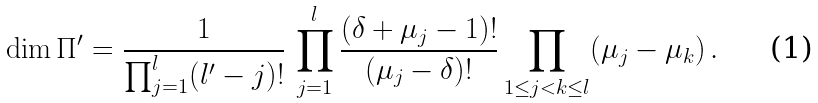Convert formula to latex. <formula><loc_0><loc_0><loc_500><loc_500>\dim \Pi ^ { \prime } = \frac { 1 } { \prod _ { j = 1 } ^ { l } ( l ^ { \prime } - j ) ! } \, \prod _ { j = 1 } ^ { l } \frac { ( \delta + \mu _ { j } - 1 ) ! } { ( \mu _ { j } - \delta ) ! } \prod _ { 1 \leq j < k \leq l } ( \mu _ { j } - \mu _ { k } ) \, .</formula> 